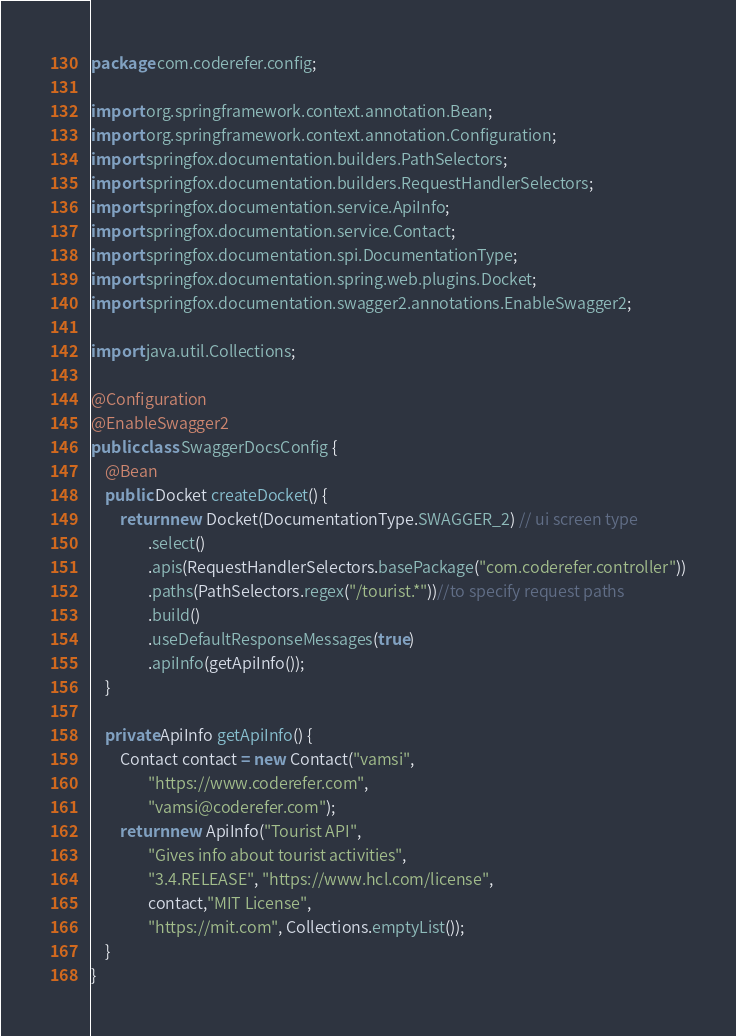<code> <loc_0><loc_0><loc_500><loc_500><_Java_>package com.coderefer.config;

import org.springframework.context.annotation.Bean;
import org.springframework.context.annotation.Configuration;
import springfox.documentation.builders.PathSelectors;
import springfox.documentation.builders.RequestHandlerSelectors;
import springfox.documentation.service.ApiInfo;
import springfox.documentation.service.Contact;
import springfox.documentation.spi.DocumentationType;
import springfox.documentation.spring.web.plugins.Docket;
import springfox.documentation.swagger2.annotations.EnableSwagger2;

import java.util.Collections;

@Configuration
@EnableSwagger2
public class SwaggerDocsConfig {
    @Bean
    public Docket createDocket() {
        return new Docket(DocumentationType.SWAGGER_2) // ui screen type
                .select()
                .apis(RequestHandlerSelectors.basePackage("com.coderefer.controller"))
                .paths(PathSelectors.regex("/tourist.*"))//to specify request paths
                .build()
                .useDefaultResponseMessages(true)
                .apiInfo(getApiInfo());
    }

    private ApiInfo getApiInfo() {
        Contact contact = new Contact("vamsi",
                "https://www.coderefer.com",
                "vamsi@coderefer.com");
        return new ApiInfo("Tourist API",
                "Gives info about tourist activities",
                "3.4.RELEASE", "https://www.hcl.com/license",
                contact,"MIT License",
                "https://mit.com", Collections.emptyList());
    }
}
</code> 